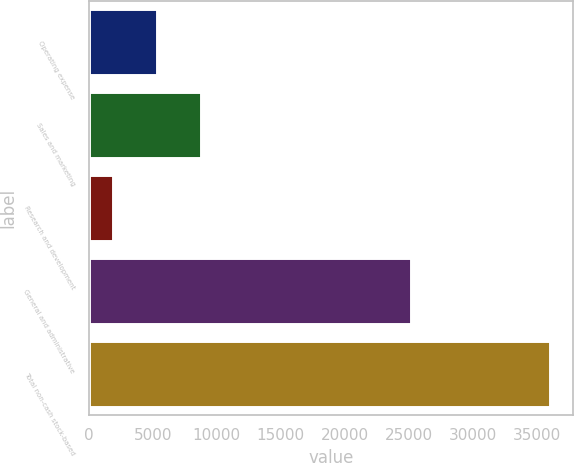<chart> <loc_0><loc_0><loc_500><loc_500><bar_chart><fcel>Operating expense<fcel>Sales and marketing<fcel>Research and development<fcel>General and administrative<fcel>Total non-cash stock-based<nl><fcel>5325.5<fcel>8739<fcel>1912<fcel>25162<fcel>36047<nl></chart> 